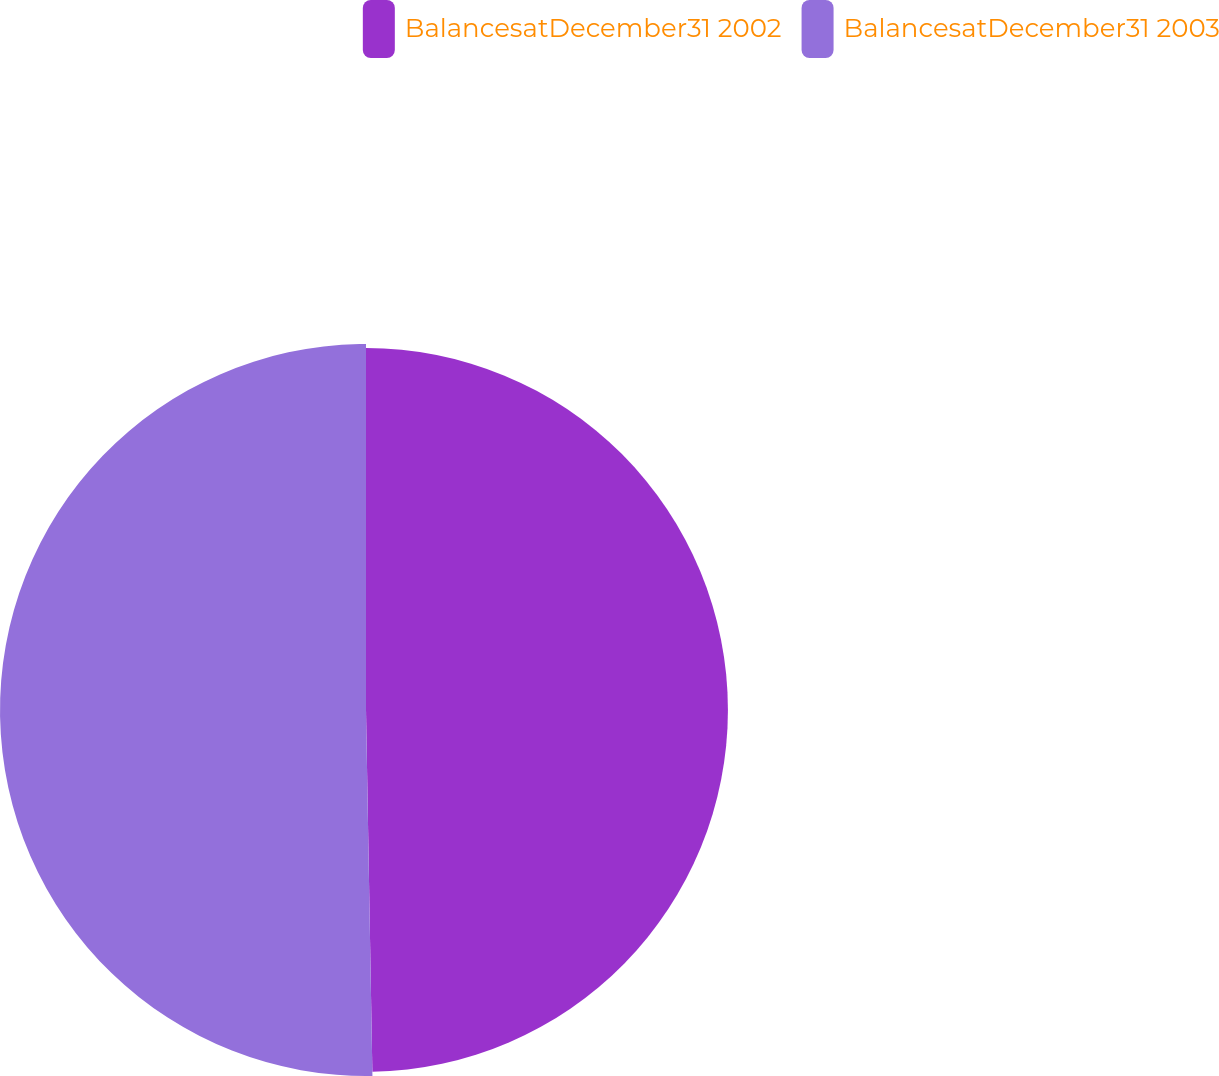Convert chart to OTSL. <chart><loc_0><loc_0><loc_500><loc_500><pie_chart><fcel>BalancesatDecember31 2002<fcel>BalancesatDecember31 2003<nl><fcel>49.72%<fcel>50.28%<nl></chart> 